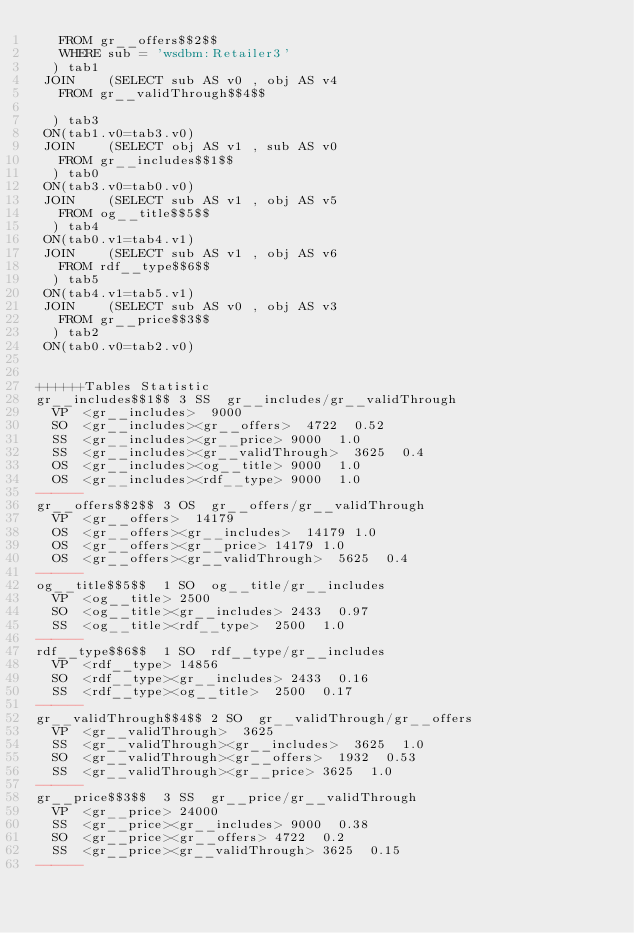Convert code to text. <code><loc_0><loc_0><loc_500><loc_500><_SQL_>	 FROM gr__offers$$2$$ 
	 WHERE sub = 'wsdbm:Retailer3'
	) tab1
 JOIN    (SELECT sub AS v0 , obj AS v4 
	 FROM gr__validThrough$$4$$
	
	) tab3
 ON(tab1.v0=tab3.v0)
 JOIN    (SELECT obj AS v1 , sub AS v0 
	 FROM gr__includes$$1$$
	) tab0
 ON(tab3.v0=tab0.v0)
 JOIN    (SELECT sub AS v1 , obj AS v5 
	 FROM og__title$$5$$
	) tab4
 ON(tab0.v1=tab4.v1)
 JOIN    (SELECT sub AS v1 , obj AS v6 
	 FROM rdf__type$$6$$
	) tab5
 ON(tab4.v1=tab5.v1)
 JOIN    (SELECT sub AS v0 , obj AS v3 
	 FROM gr__price$$3$$
	) tab2
 ON(tab0.v0=tab2.v0)


++++++Tables Statistic
gr__includes$$1$$	3	SS	gr__includes/gr__validThrough
	VP	<gr__includes>	9000
	SO	<gr__includes><gr__offers>	4722	0.52
	SS	<gr__includes><gr__price>	9000	1.0
	SS	<gr__includes><gr__validThrough>	3625	0.4
	OS	<gr__includes><og__title>	9000	1.0
	OS	<gr__includes><rdf__type>	9000	1.0
------
gr__offers$$2$$	3	OS	gr__offers/gr__validThrough
	VP	<gr__offers>	14179
	OS	<gr__offers><gr__includes>	14179	1.0
	OS	<gr__offers><gr__price>	14179	1.0
	OS	<gr__offers><gr__validThrough>	5625	0.4
------
og__title$$5$$	1	SO	og__title/gr__includes
	VP	<og__title>	2500
	SO	<og__title><gr__includes>	2433	0.97
	SS	<og__title><rdf__type>	2500	1.0
------
rdf__type$$6$$	1	SO	rdf__type/gr__includes
	VP	<rdf__type>	14856
	SO	<rdf__type><gr__includes>	2433	0.16
	SS	<rdf__type><og__title>	2500	0.17
------
gr__validThrough$$4$$	2	SO	gr__validThrough/gr__offers
	VP	<gr__validThrough>	3625
	SS	<gr__validThrough><gr__includes>	3625	1.0
	SO	<gr__validThrough><gr__offers>	1932	0.53
	SS	<gr__validThrough><gr__price>	3625	1.0
------
gr__price$$3$$	3	SS	gr__price/gr__validThrough
	VP	<gr__price>	24000
	SS	<gr__price><gr__includes>	9000	0.38
	SO	<gr__price><gr__offers>	4722	0.2
	SS	<gr__price><gr__validThrough>	3625	0.15
------
</code> 